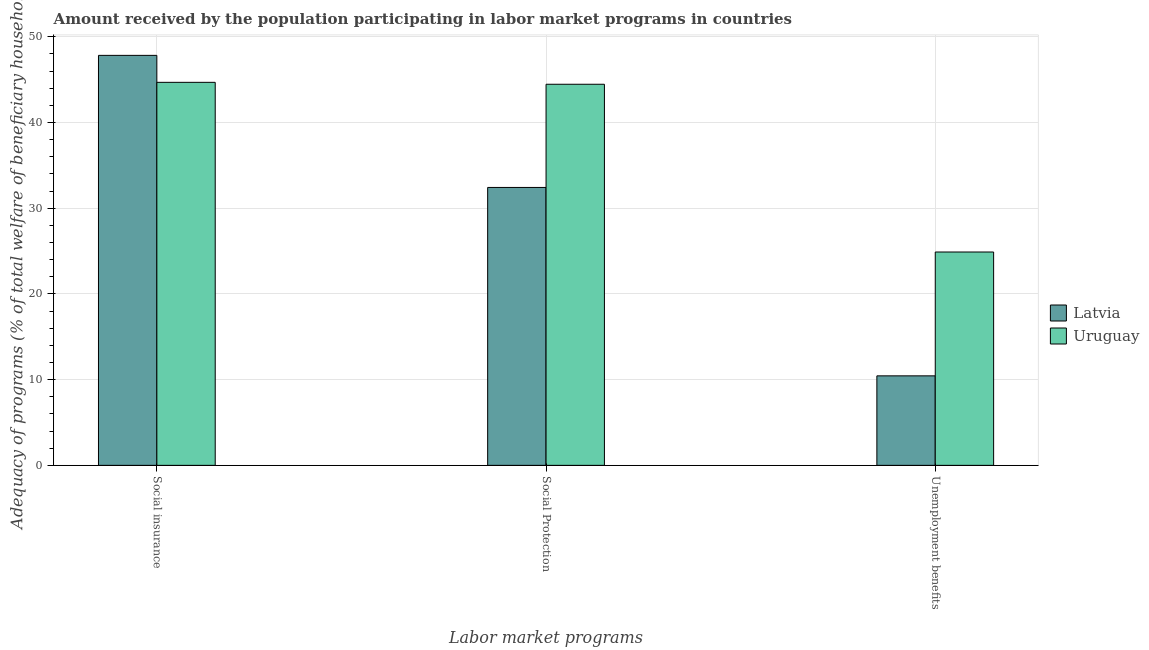How many groups of bars are there?
Make the answer very short. 3. Are the number of bars on each tick of the X-axis equal?
Offer a terse response. Yes. How many bars are there on the 2nd tick from the right?
Make the answer very short. 2. What is the label of the 3rd group of bars from the left?
Keep it short and to the point. Unemployment benefits. What is the amount received by the population participating in social insurance programs in Latvia?
Your answer should be compact. 47.82. Across all countries, what is the maximum amount received by the population participating in unemployment benefits programs?
Offer a terse response. 24.89. Across all countries, what is the minimum amount received by the population participating in unemployment benefits programs?
Your answer should be very brief. 10.44. In which country was the amount received by the population participating in social insurance programs maximum?
Give a very brief answer. Latvia. In which country was the amount received by the population participating in unemployment benefits programs minimum?
Give a very brief answer. Latvia. What is the total amount received by the population participating in social protection programs in the graph?
Your answer should be very brief. 76.87. What is the difference between the amount received by the population participating in social protection programs in Latvia and that in Uruguay?
Provide a succinct answer. -12.04. What is the difference between the amount received by the population participating in social insurance programs in Uruguay and the amount received by the population participating in social protection programs in Latvia?
Keep it short and to the point. 12.26. What is the average amount received by the population participating in social protection programs per country?
Give a very brief answer. 38.44. What is the difference between the amount received by the population participating in unemployment benefits programs and amount received by the population participating in social protection programs in Uruguay?
Your answer should be very brief. -19.57. In how many countries, is the amount received by the population participating in unemployment benefits programs greater than 10 %?
Your response must be concise. 2. What is the ratio of the amount received by the population participating in social insurance programs in Uruguay to that in Latvia?
Give a very brief answer. 0.93. What is the difference between the highest and the second highest amount received by the population participating in social insurance programs?
Provide a succinct answer. 3.15. What is the difference between the highest and the lowest amount received by the population participating in social insurance programs?
Make the answer very short. 3.15. Is the sum of the amount received by the population participating in social protection programs in Latvia and Uruguay greater than the maximum amount received by the population participating in social insurance programs across all countries?
Your answer should be compact. Yes. What does the 2nd bar from the left in Social Protection represents?
Offer a very short reply. Uruguay. What does the 1st bar from the right in Social Protection represents?
Offer a very short reply. Uruguay. How many bars are there?
Ensure brevity in your answer.  6. Are all the bars in the graph horizontal?
Provide a short and direct response. No. How many countries are there in the graph?
Offer a very short reply. 2. What is the difference between two consecutive major ticks on the Y-axis?
Your answer should be compact. 10. Are the values on the major ticks of Y-axis written in scientific E-notation?
Offer a very short reply. No. Does the graph contain any zero values?
Provide a short and direct response. No. How many legend labels are there?
Your response must be concise. 2. What is the title of the graph?
Keep it short and to the point. Amount received by the population participating in labor market programs in countries. Does "Lebanon" appear as one of the legend labels in the graph?
Ensure brevity in your answer.  No. What is the label or title of the X-axis?
Make the answer very short. Labor market programs. What is the label or title of the Y-axis?
Offer a very short reply. Adequacy of programs (% of total welfare of beneficiary households). What is the Adequacy of programs (% of total welfare of beneficiary households) of Latvia in Social insurance?
Your answer should be compact. 47.82. What is the Adequacy of programs (% of total welfare of beneficiary households) of Uruguay in Social insurance?
Offer a terse response. 44.68. What is the Adequacy of programs (% of total welfare of beneficiary households) of Latvia in Social Protection?
Your answer should be compact. 32.42. What is the Adequacy of programs (% of total welfare of beneficiary households) of Uruguay in Social Protection?
Provide a short and direct response. 44.45. What is the Adequacy of programs (% of total welfare of beneficiary households) of Latvia in Unemployment benefits?
Your answer should be very brief. 10.44. What is the Adequacy of programs (% of total welfare of beneficiary households) in Uruguay in Unemployment benefits?
Your answer should be compact. 24.89. Across all Labor market programs, what is the maximum Adequacy of programs (% of total welfare of beneficiary households) in Latvia?
Your response must be concise. 47.82. Across all Labor market programs, what is the maximum Adequacy of programs (% of total welfare of beneficiary households) in Uruguay?
Provide a short and direct response. 44.68. Across all Labor market programs, what is the minimum Adequacy of programs (% of total welfare of beneficiary households) of Latvia?
Your answer should be very brief. 10.44. Across all Labor market programs, what is the minimum Adequacy of programs (% of total welfare of beneficiary households) in Uruguay?
Your answer should be very brief. 24.89. What is the total Adequacy of programs (% of total welfare of beneficiary households) in Latvia in the graph?
Provide a succinct answer. 90.68. What is the total Adequacy of programs (% of total welfare of beneficiary households) in Uruguay in the graph?
Give a very brief answer. 114.02. What is the difference between the Adequacy of programs (% of total welfare of beneficiary households) in Latvia in Social insurance and that in Social Protection?
Your answer should be very brief. 15.41. What is the difference between the Adequacy of programs (% of total welfare of beneficiary households) in Uruguay in Social insurance and that in Social Protection?
Provide a short and direct response. 0.22. What is the difference between the Adequacy of programs (% of total welfare of beneficiary households) of Latvia in Social insurance and that in Unemployment benefits?
Keep it short and to the point. 37.38. What is the difference between the Adequacy of programs (% of total welfare of beneficiary households) of Uruguay in Social insurance and that in Unemployment benefits?
Your answer should be very brief. 19.79. What is the difference between the Adequacy of programs (% of total welfare of beneficiary households) of Latvia in Social Protection and that in Unemployment benefits?
Offer a terse response. 21.98. What is the difference between the Adequacy of programs (% of total welfare of beneficiary households) of Uruguay in Social Protection and that in Unemployment benefits?
Keep it short and to the point. 19.57. What is the difference between the Adequacy of programs (% of total welfare of beneficiary households) in Latvia in Social insurance and the Adequacy of programs (% of total welfare of beneficiary households) in Uruguay in Social Protection?
Your response must be concise. 3.37. What is the difference between the Adequacy of programs (% of total welfare of beneficiary households) in Latvia in Social insurance and the Adequacy of programs (% of total welfare of beneficiary households) in Uruguay in Unemployment benefits?
Provide a succinct answer. 22.94. What is the difference between the Adequacy of programs (% of total welfare of beneficiary households) in Latvia in Social Protection and the Adequacy of programs (% of total welfare of beneficiary households) in Uruguay in Unemployment benefits?
Offer a very short reply. 7.53. What is the average Adequacy of programs (% of total welfare of beneficiary households) of Latvia per Labor market programs?
Your answer should be very brief. 30.23. What is the average Adequacy of programs (% of total welfare of beneficiary households) of Uruguay per Labor market programs?
Offer a very short reply. 38.01. What is the difference between the Adequacy of programs (% of total welfare of beneficiary households) of Latvia and Adequacy of programs (% of total welfare of beneficiary households) of Uruguay in Social insurance?
Give a very brief answer. 3.15. What is the difference between the Adequacy of programs (% of total welfare of beneficiary households) of Latvia and Adequacy of programs (% of total welfare of beneficiary households) of Uruguay in Social Protection?
Your response must be concise. -12.04. What is the difference between the Adequacy of programs (% of total welfare of beneficiary households) in Latvia and Adequacy of programs (% of total welfare of beneficiary households) in Uruguay in Unemployment benefits?
Keep it short and to the point. -14.45. What is the ratio of the Adequacy of programs (% of total welfare of beneficiary households) of Latvia in Social insurance to that in Social Protection?
Your answer should be very brief. 1.48. What is the ratio of the Adequacy of programs (% of total welfare of beneficiary households) in Uruguay in Social insurance to that in Social Protection?
Your answer should be very brief. 1. What is the ratio of the Adequacy of programs (% of total welfare of beneficiary households) in Latvia in Social insurance to that in Unemployment benefits?
Offer a terse response. 4.58. What is the ratio of the Adequacy of programs (% of total welfare of beneficiary households) of Uruguay in Social insurance to that in Unemployment benefits?
Your answer should be very brief. 1.8. What is the ratio of the Adequacy of programs (% of total welfare of beneficiary households) in Latvia in Social Protection to that in Unemployment benefits?
Offer a very short reply. 3.1. What is the ratio of the Adequacy of programs (% of total welfare of beneficiary households) in Uruguay in Social Protection to that in Unemployment benefits?
Make the answer very short. 1.79. What is the difference between the highest and the second highest Adequacy of programs (% of total welfare of beneficiary households) in Latvia?
Your response must be concise. 15.41. What is the difference between the highest and the second highest Adequacy of programs (% of total welfare of beneficiary households) of Uruguay?
Offer a very short reply. 0.22. What is the difference between the highest and the lowest Adequacy of programs (% of total welfare of beneficiary households) in Latvia?
Your answer should be compact. 37.38. What is the difference between the highest and the lowest Adequacy of programs (% of total welfare of beneficiary households) of Uruguay?
Offer a very short reply. 19.79. 